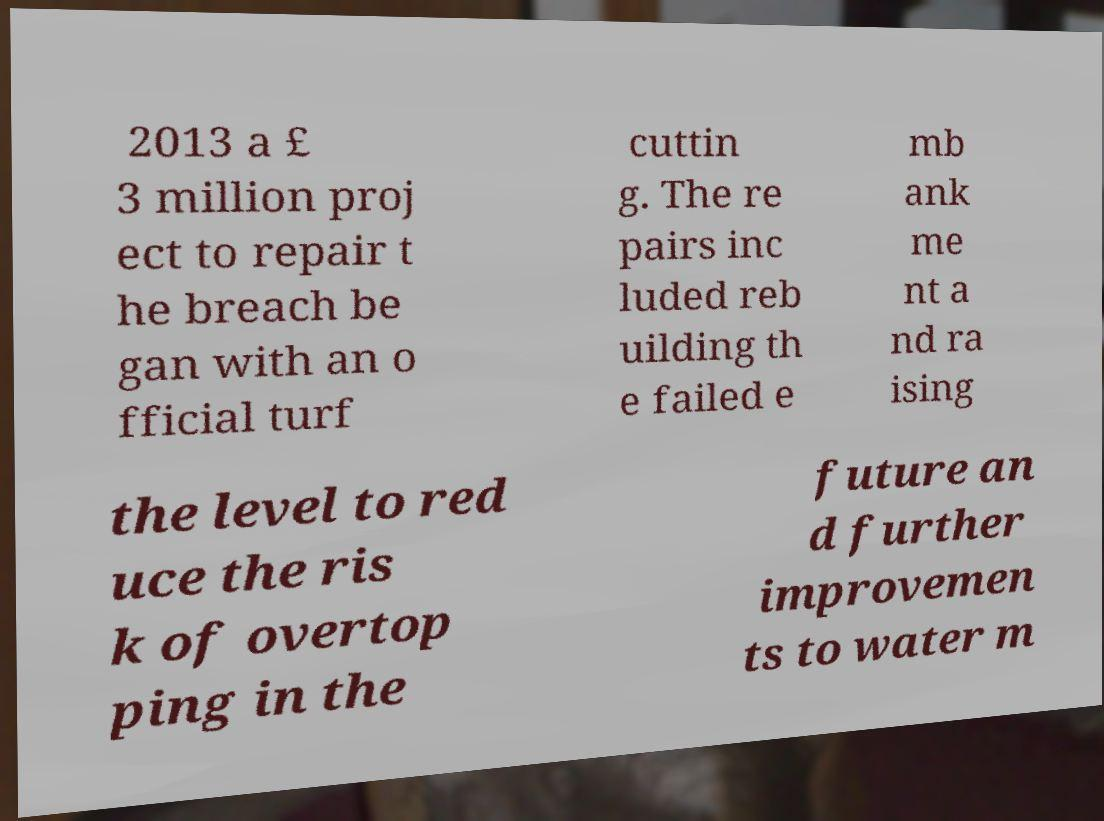Please read and relay the text visible in this image. What does it say? 2013 a £ 3 million proj ect to repair t he breach be gan with an o fficial turf cuttin g. The re pairs inc luded reb uilding th e failed e mb ank me nt a nd ra ising the level to red uce the ris k of overtop ping in the future an d further improvemen ts to water m 